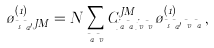<formula> <loc_0><loc_0><loc_500><loc_500>\tau ^ { ( 1 ) } _ { \mu _ { s } \mu _ { a ^ { \prime } } J M } = N \sum _ { \mu _ { a } \mu _ { v } } C ^ { J M } _ { j _ { a } \mu _ { a } \, j _ { v } \mu _ { v } } \tau ^ { ( 1 ) } _ { \mu _ { s } \mu _ { a ^ { \prime } } \mu _ { v } \mu _ { a } } \, ,</formula> 